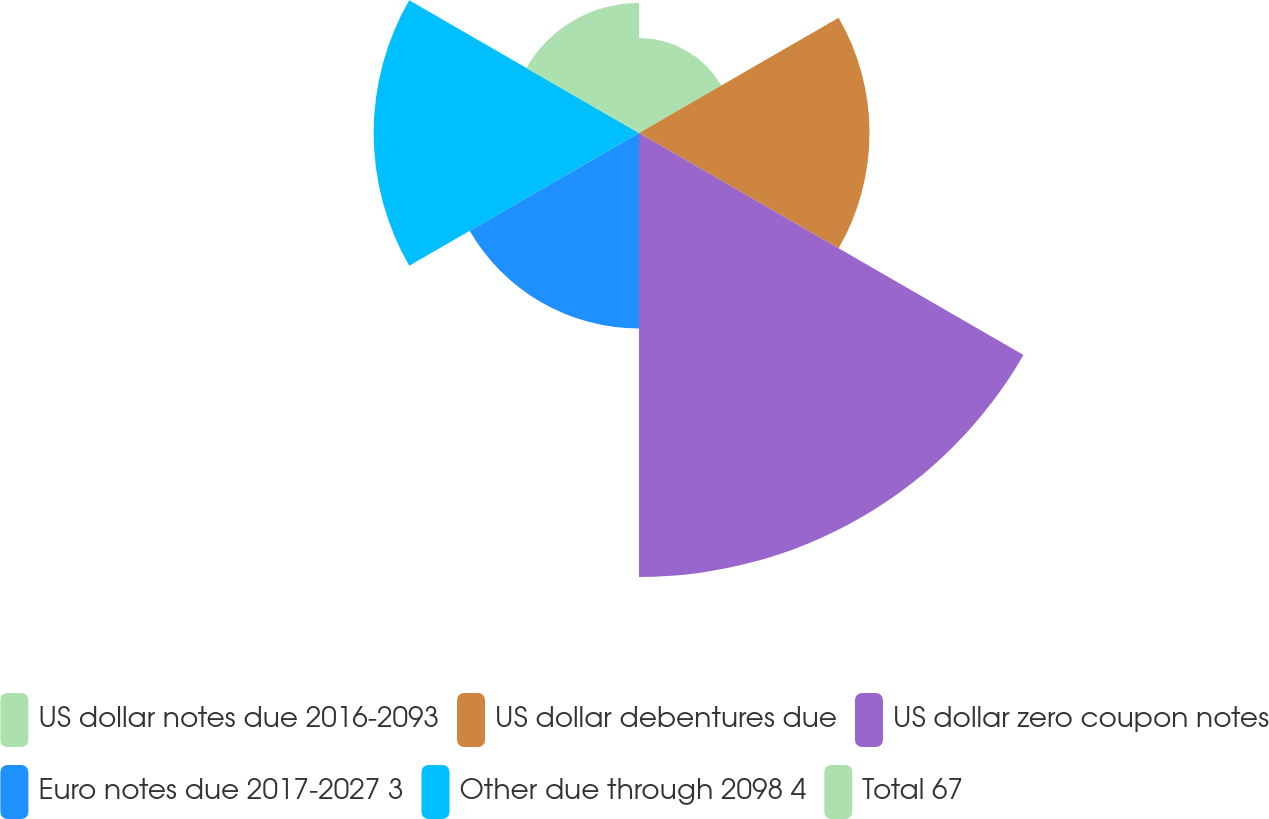Convert chart. <chart><loc_0><loc_0><loc_500><loc_500><pie_chart><fcel>US dollar notes due 2016-2093<fcel>US dollar debentures due<fcel>US dollar zero coupon notes<fcel>Euro notes due 2017-2027 3<fcel>Other due through 2098 4<fcel>Total 67<nl><fcel>6.99%<fcel>16.94%<fcel>32.63%<fcel>14.37%<fcel>19.5%<fcel>9.56%<nl></chart> 